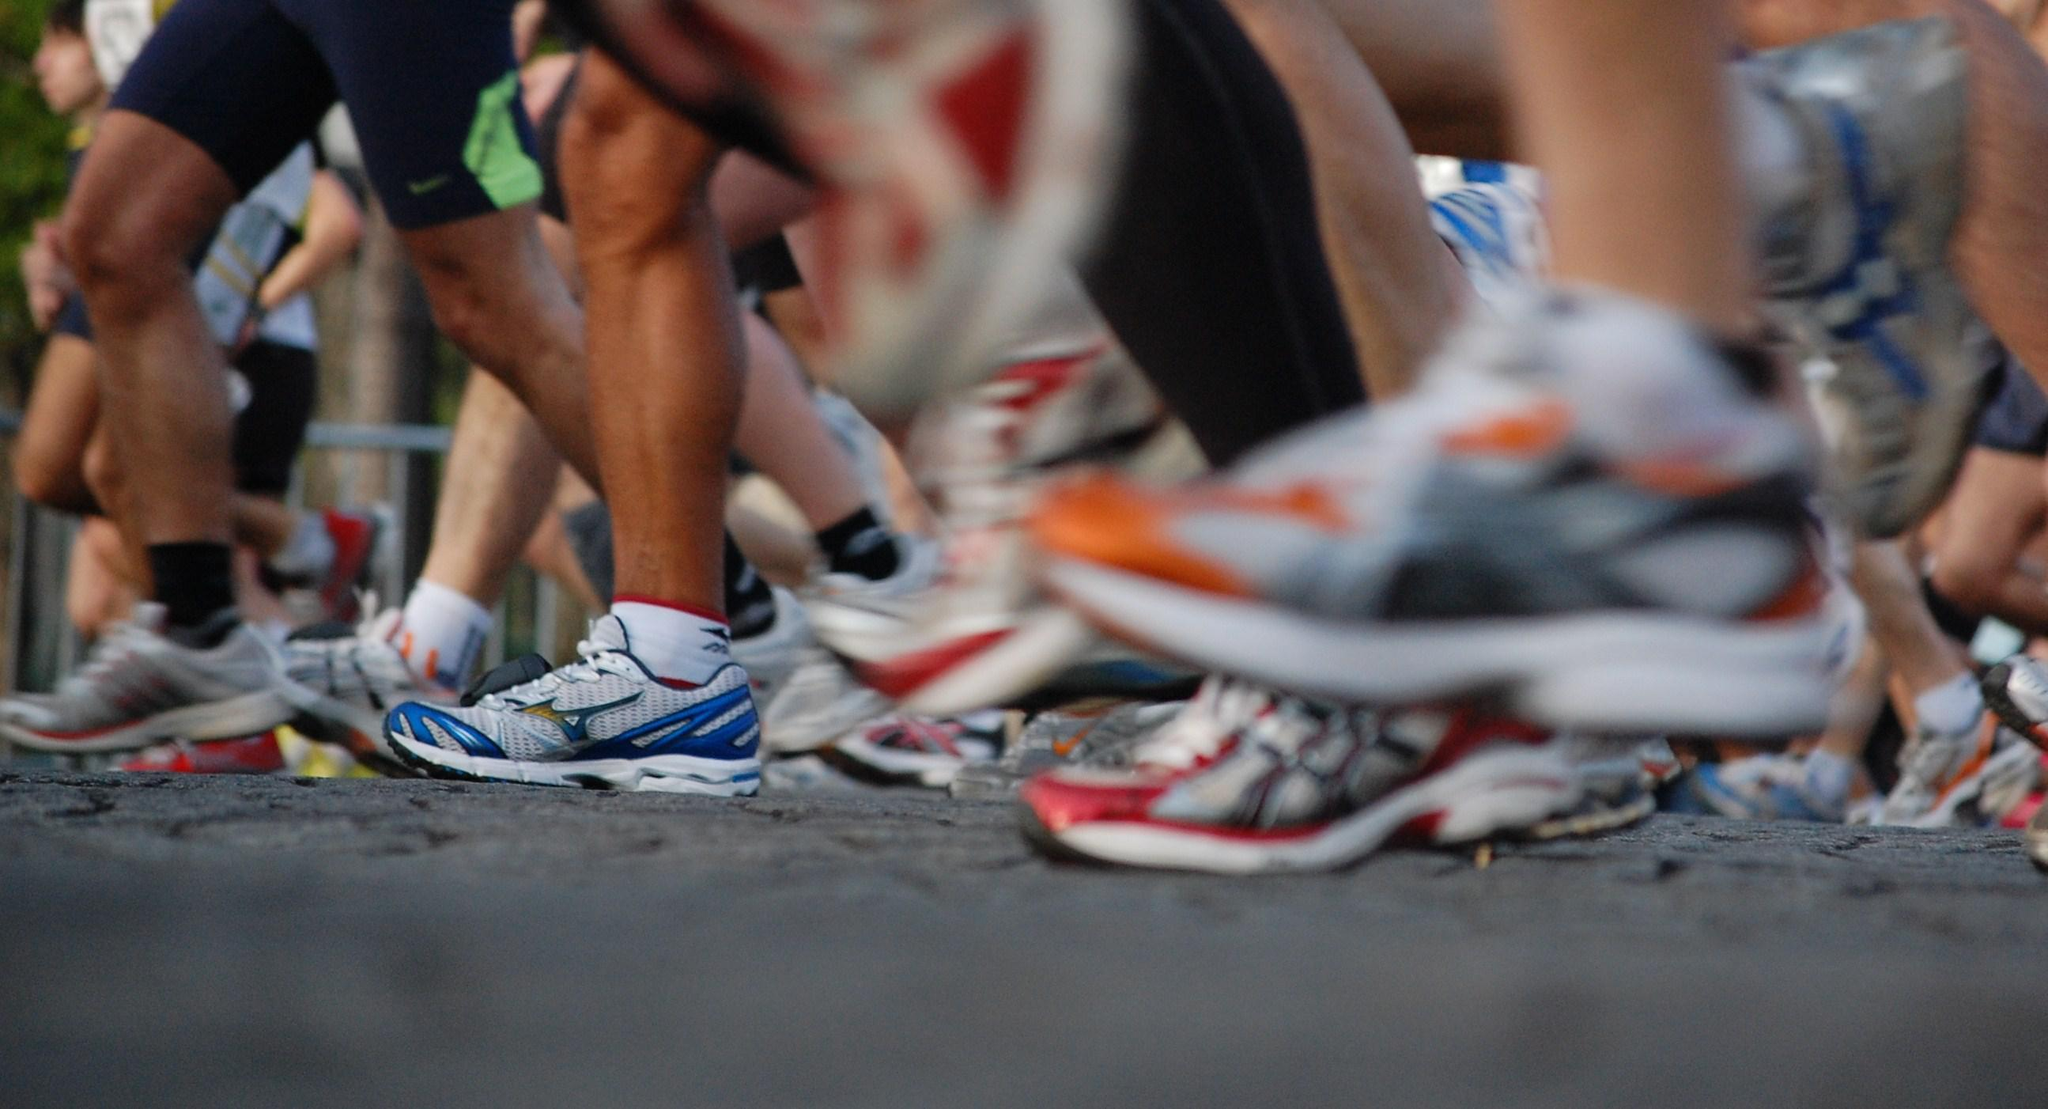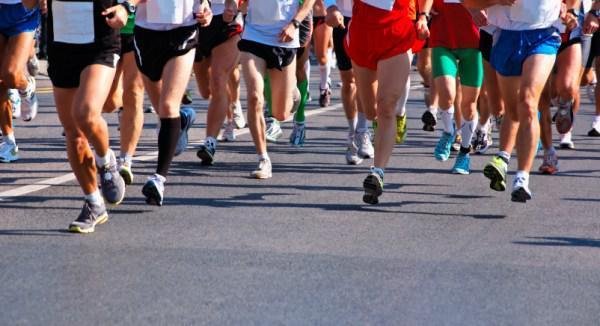The first image is the image on the left, the second image is the image on the right. Evaluate the accuracy of this statement regarding the images: "The feet and legs of many people running in a race are shown.". Is it true? Answer yes or no. Yes. The first image is the image on the left, the second image is the image on the right. Evaluate the accuracy of this statement regarding the images: "There are two shoes in the left image". Is it true? Answer yes or no. No. 